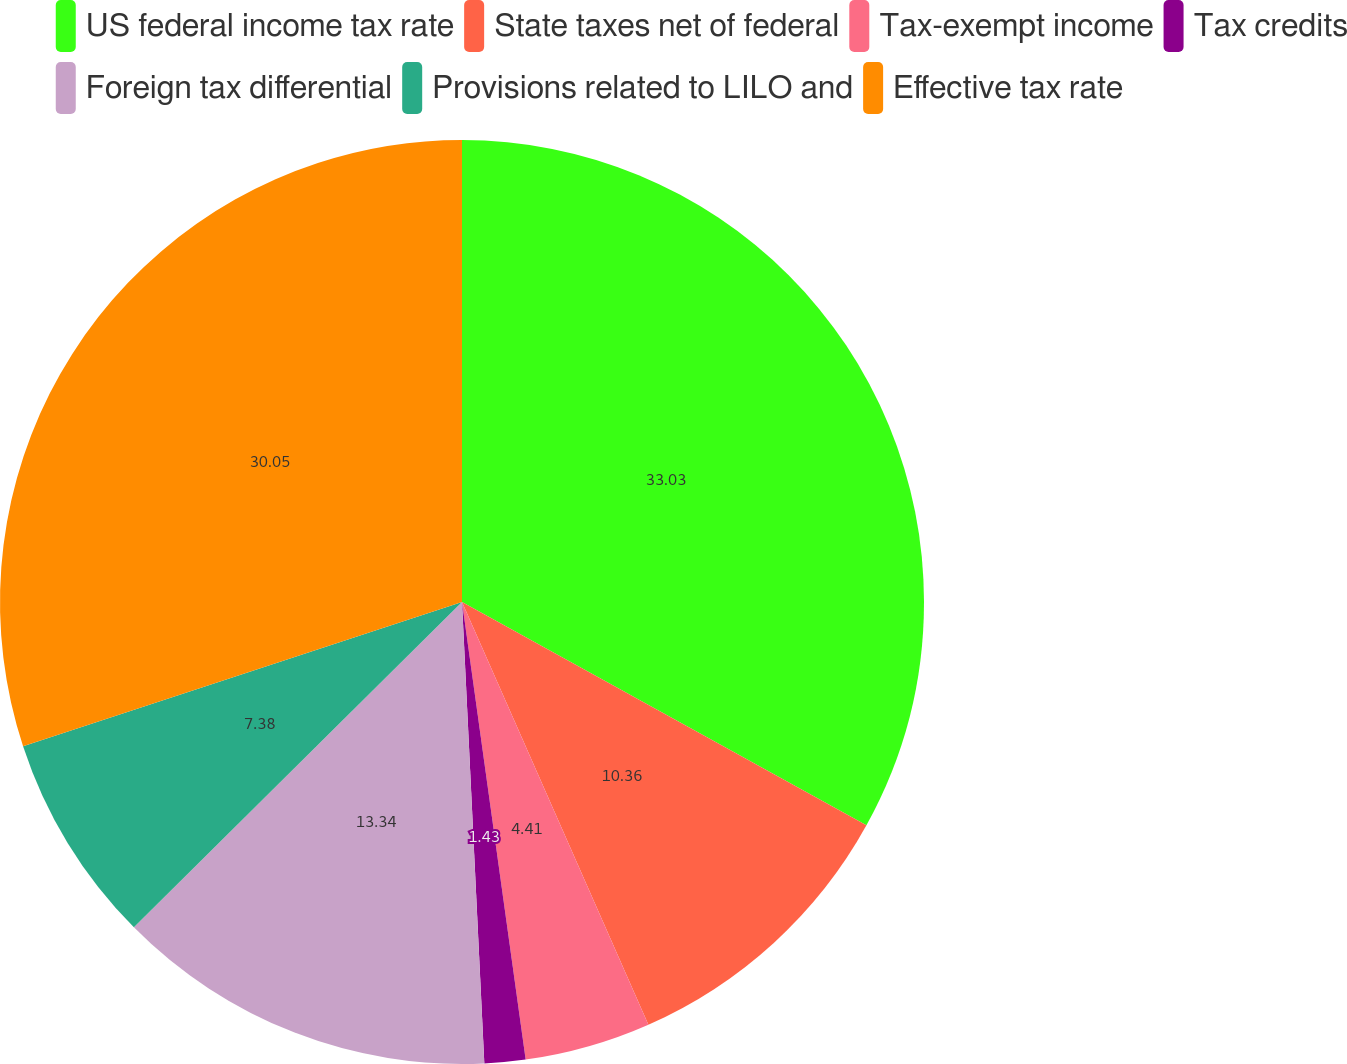Convert chart to OTSL. <chart><loc_0><loc_0><loc_500><loc_500><pie_chart><fcel>US federal income tax rate<fcel>State taxes net of federal<fcel>Tax-exempt income<fcel>Tax credits<fcel>Foreign tax differential<fcel>Provisions related to LILO and<fcel>Effective tax rate<nl><fcel>33.03%<fcel>10.36%<fcel>4.41%<fcel>1.43%<fcel>13.34%<fcel>7.38%<fcel>30.05%<nl></chart> 